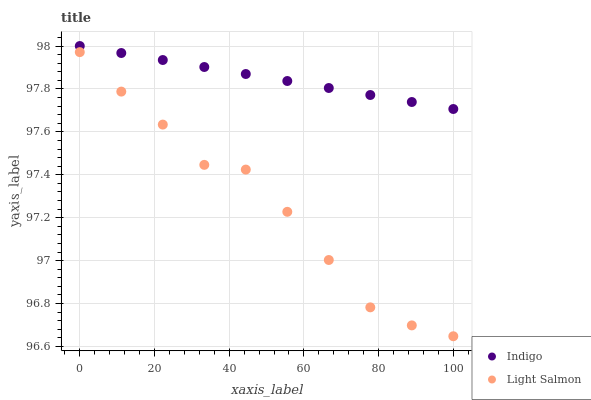Does Light Salmon have the minimum area under the curve?
Answer yes or no. Yes. Does Indigo have the maximum area under the curve?
Answer yes or no. Yes. Does Indigo have the minimum area under the curve?
Answer yes or no. No. Is Indigo the smoothest?
Answer yes or no. Yes. Is Light Salmon the roughest?
Answer yes or no. Yes. Is Indigo the roughest?
Answer yes or no. No. Does Light Salmon have the lowest value?
Answer yes or no. Yes. Does Indigo have the lowest value?
Answer yes or no. No. Does Indigo have the highest value?
Answer yes or no. Yes. Is Light Salmon less than Indigo?
Answer yes or no. Yes. Is Indigo greater than Light Salmon?
Answer yes or no. Yes. Does Light Salmon intersect Indigo?
Answer yes or no. No. 